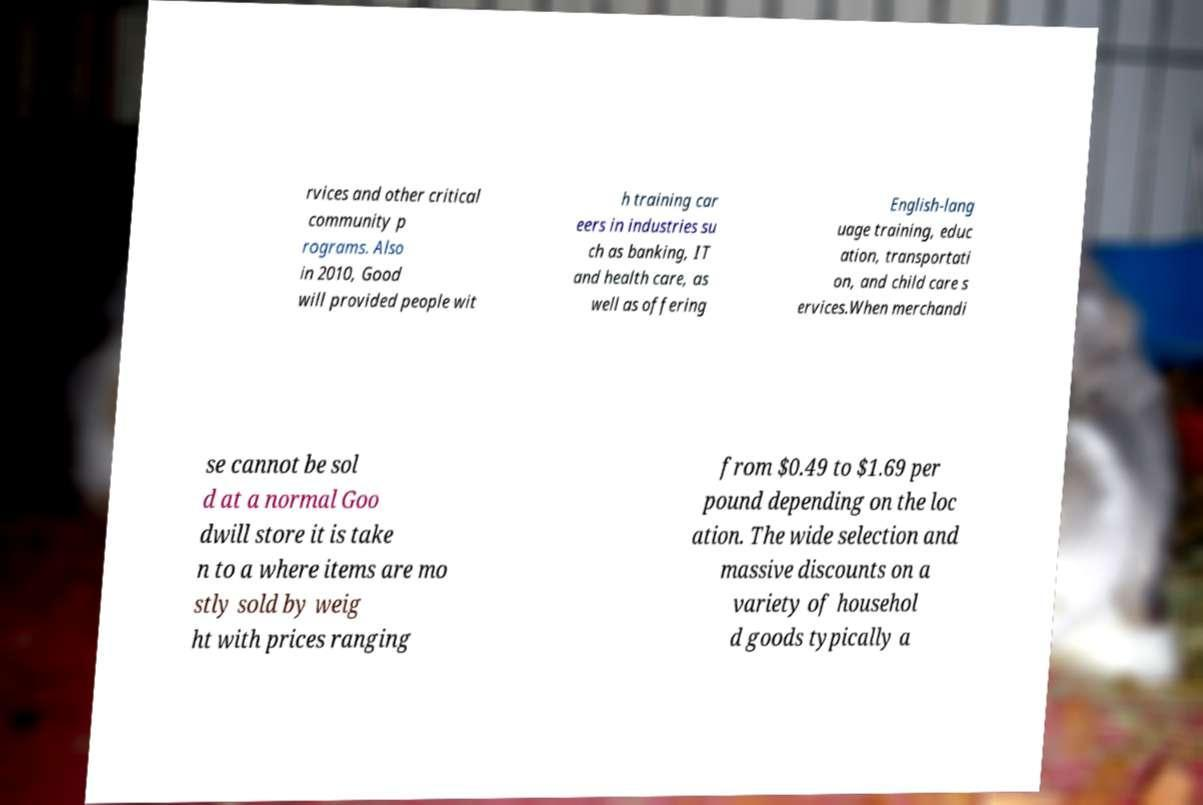Please identify and transcribe the text found in this image. rvices and other critical community p rograms. Also in 2010, Good will provided people wit h training car eers in industries su ch as banking, IT and health care, as well as offering English-lang uage training, educ ation, transportati on, and child care s ervices.When merchandi se cannot be sol d at a normal Goo dwill store it is take n to a where items are mo stly sold by weig ht with prices ranging from $0.49 to $1.69 per pound depending on the loc ation. The wide selection and massive discounts on a variety of househol d goods typically a 